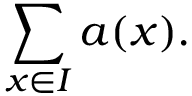Convert formula to latex. <formula><loc_0><loc_0><loc_500><loc_500>\sum _ { x \in I } a ( x ) .</formula> 